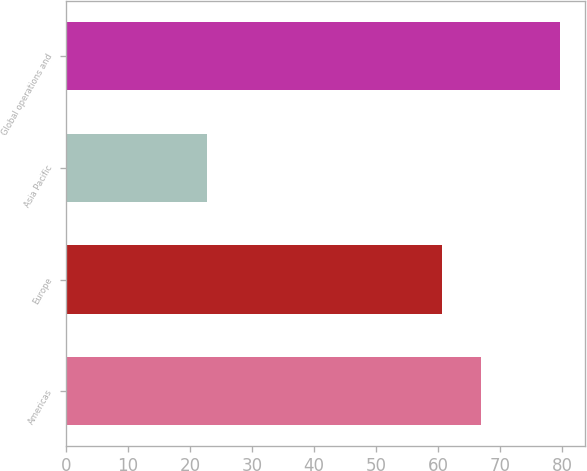<chart> <loc_0><loc_0><loc_500><loc_500><bar_chart><fcel>Americas<fcel>Europe<fcel>Asia Pacific<fcel>Global operations and<nl><fcel>66.9<fcel>60.7<fcel>22.7<fcel>79.7<nl></chart> 